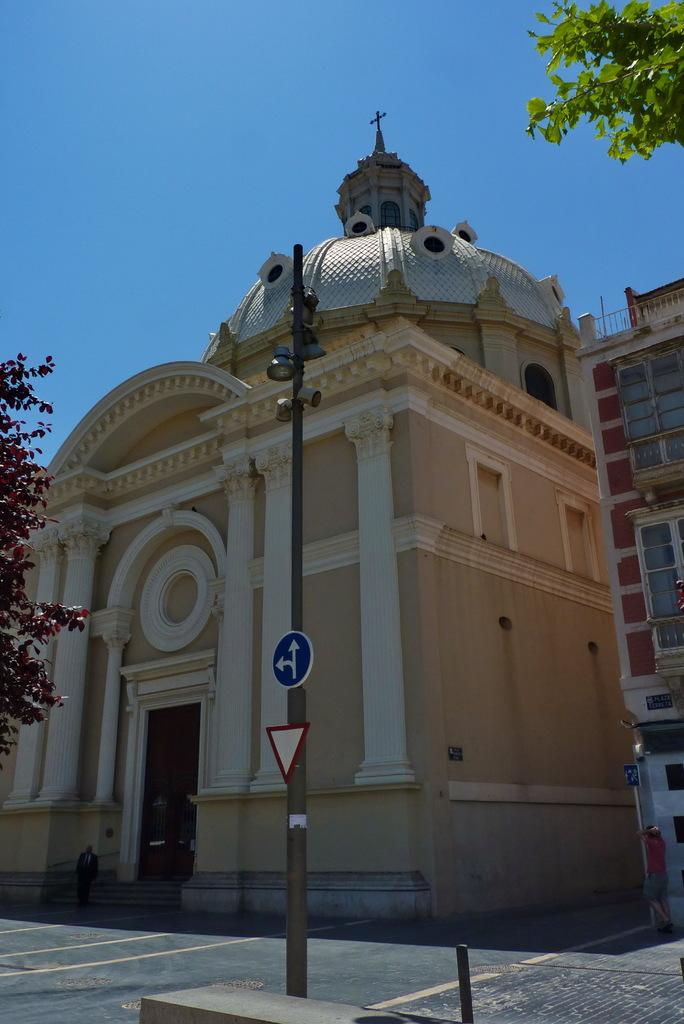What is attached to the pole in the image? There are boards and lights attached to the pole in the image. What type of vegetation can be seen in the image? There are trees visible in the image. What can be seen in the background of the image? There are buildings and the sky visible in the background of the image. How many pies are displayed on the shelves in the store in the image? There is no store or pies present in the image. Can you describe the boot that is hanging from the pole in the image? There is no boot hanging from the pole in the image; only boards and lights are attached to the pole. 